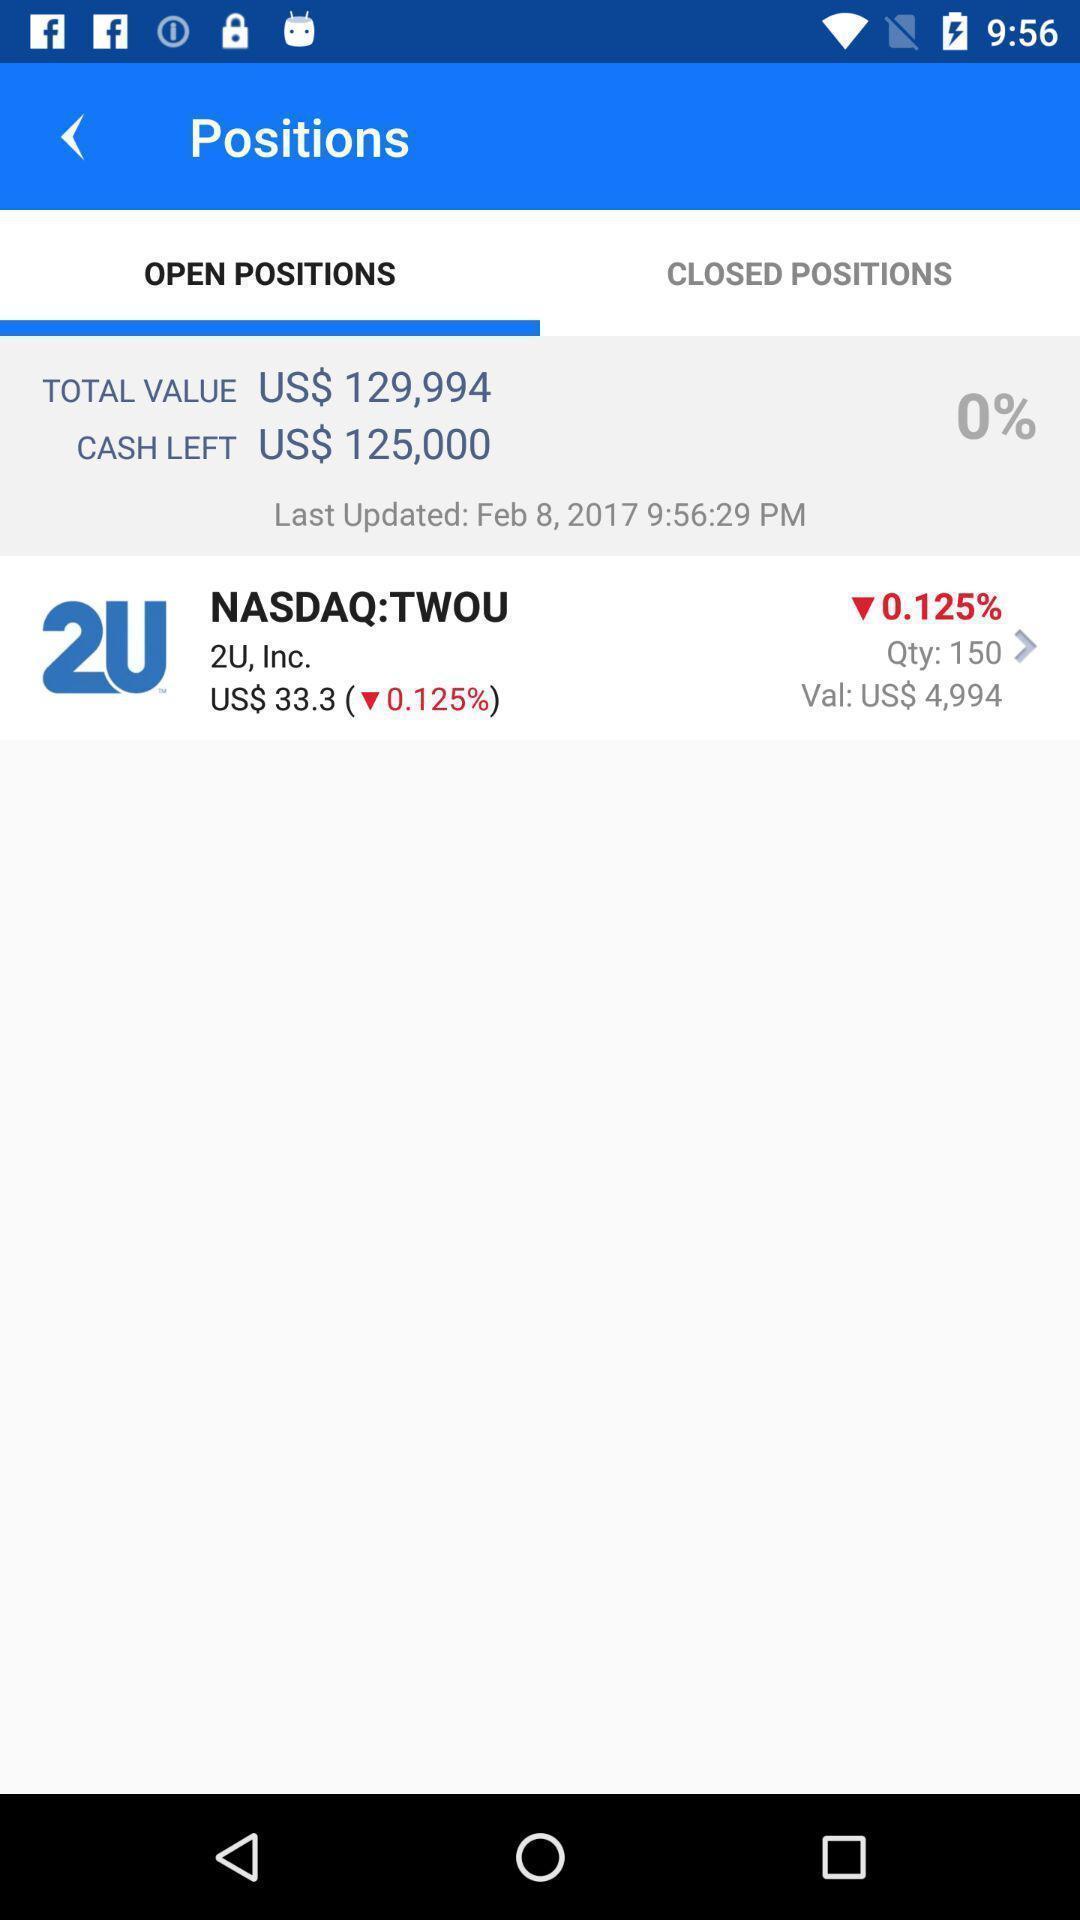Summarize the main components in this picture. Screen showing open position in trading app. 